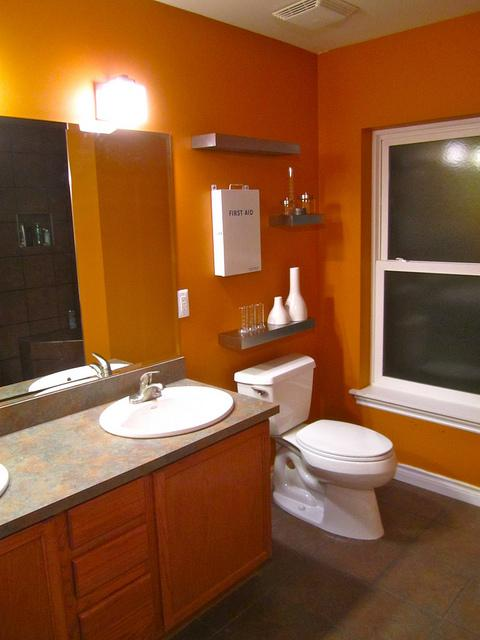What is the toilet near? window 